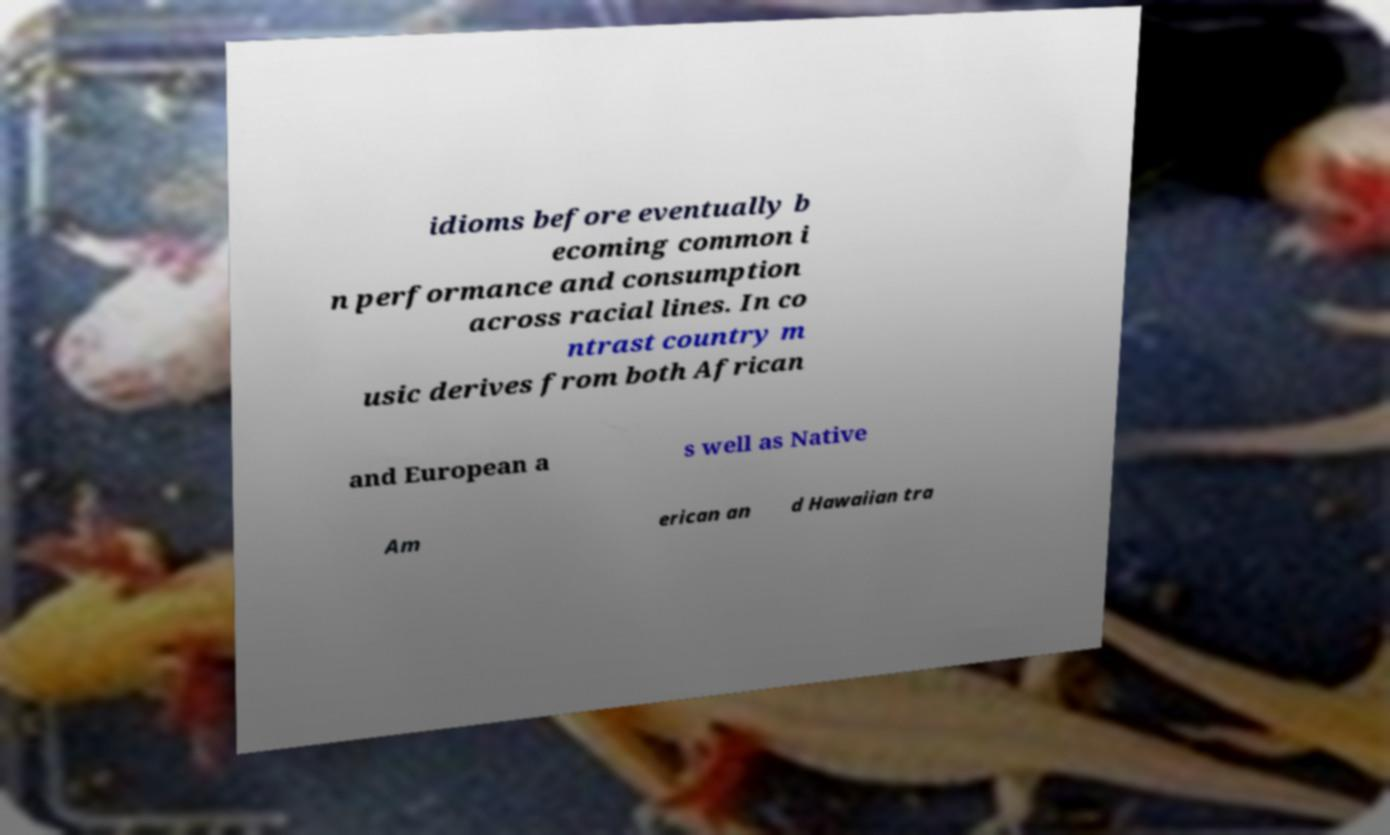Could you extract and type out the text from this image? idioms before eventually b ecoming common i n performance and consumption across racial lines. In co ntrast country m usic derives from both African and European a s well as Native Am erican an d Hawaiian tra 